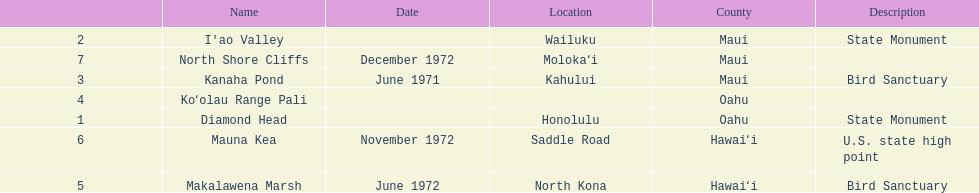What is the only name listed without a location? Koʻolau Range Pali. 